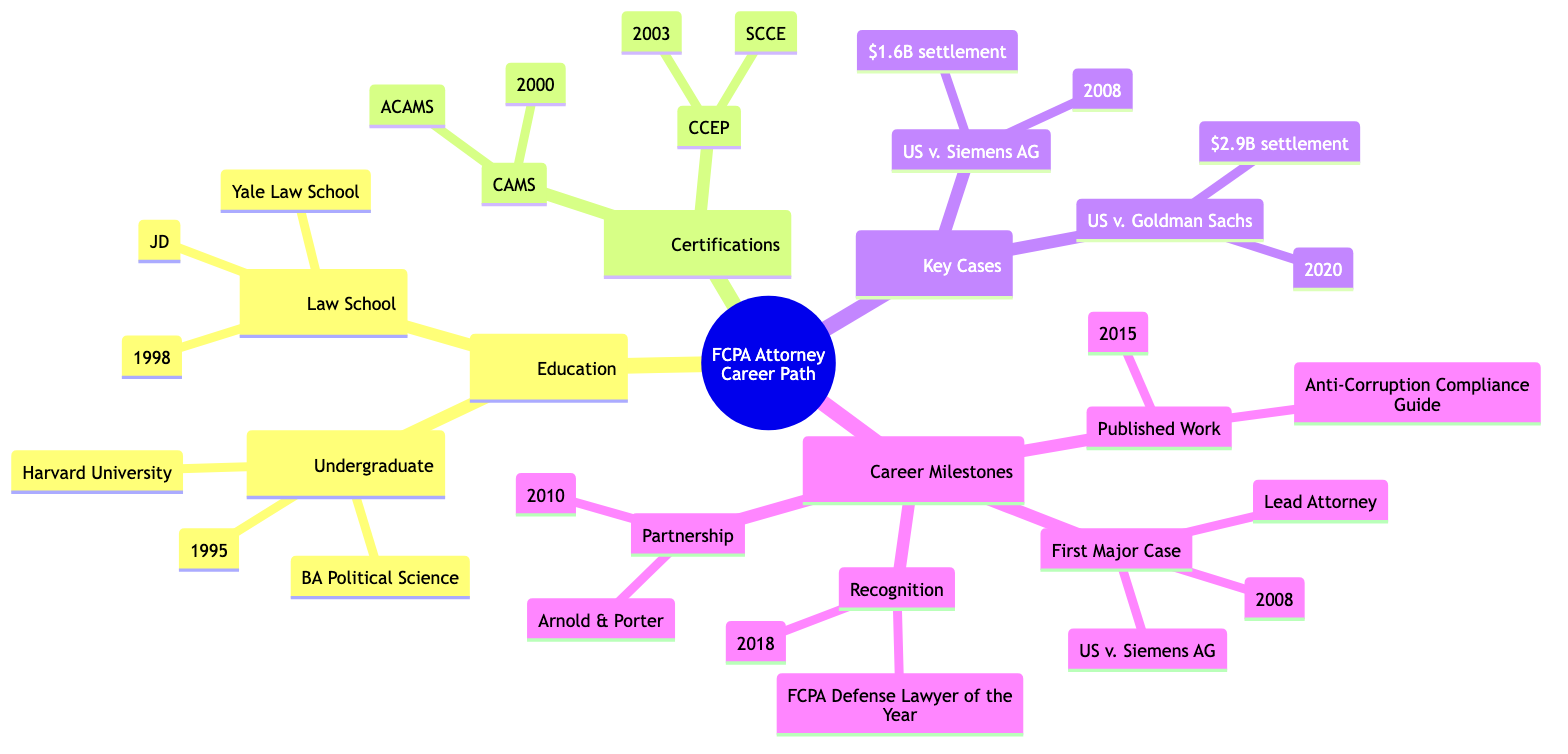What undergraduate degree does the attorney have? The attorney has a Bachelor of Arts in Political Science from Harvard University. This information can be found in the 'Education' section under 'Undergraduate Degree'.
Answer: Bachelor of Arts in Political Science What year did the attorney graduate from law school? The attorney graduated from Yale Law School in 1998. This year is listed under the 'Law School' section in the 'Education' part of the diagram.
Answer: 1998 How many certifications does the attorney have? The attorney has two certifications listed under the 'Certifications' section, which are CAMS and CCEP. Thus, by counting the number of items in this category, we find the answer.
Answer: 2 What was the significance of the case United States v. Siemens AG? The significance is that it involved handling defense in one of the largest FCPA cases resulting in a $1.6 billion settlement. This information is detailed in the 'Key Cases' section.
Answer: Handled defense in one of the largest FCPA cases, resulting in a $1.6 billion settlement Which organization awarded the attorney the "FCPA Defense Lawyer of the Year"? The award was issued by Chambers and Partners. It is stated in the 'Recognition' section under 'Career Milestones'.
Answer: Chambers and Partners What role did the attorney have in the first major case? The role of the attorney in the first major case was Lead Attorney, as noted in the 'Career Milestones' section. This is a direct reference to the 'First Major Case' node.
Answer: Lead Attorney Which case was involved in the partnership promotion? The partnership promotion does not specifically mention a case; however, the attorney's first major case, United States v. Siemens AG, connects with the attorney’s career trajectory, serving as an essential milestone. This reasoning connects both nodes.
Answer: United States v. Siemens AG What publishing house released the attorney’s published work? The attorney’s published work, titled "Anti-Corruption Compliance: A Legal Practitioner’s Guide," was published by Wiley, as detailed in the 'Published Work' node under 'Career Milestones'.
Answer: Wiley 